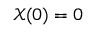Convert formula to latex. <formula><loc_0><loc_0><loc_500><loc_500>\mathcal { X } ( 0 ) = 0</formula> 